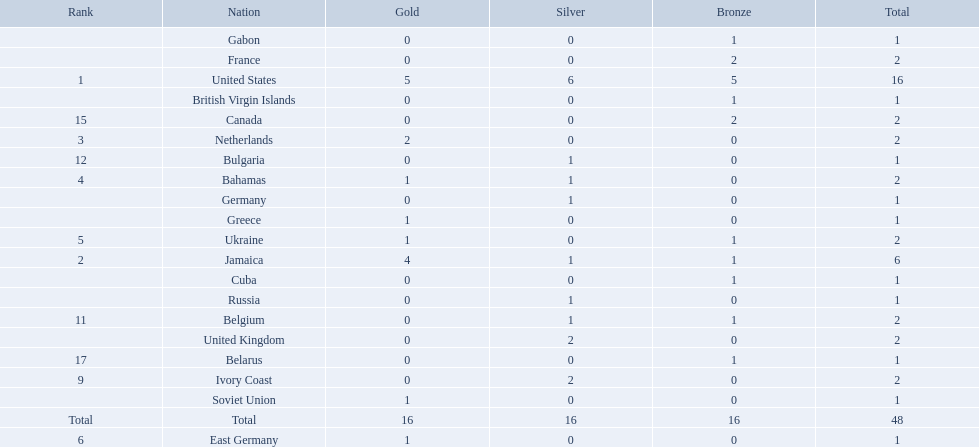What countries competed? United States, Jamaica, Netherlands, Bahamas, Ukraine, East Germany, Greece, Soviet Union, Ivory Coast, United Kingdom, Belgium, Bulgaria, Russia, Germany, Canada, France, Belarus, Cuba, Gabon, British Virgin Islands. Which countries won gold medals? United States, Jamaica, Netherlands, Bahamas, Ukraine, East Germany, Greece, Soviet Union. Which country had the second most medals? Jamaica. 